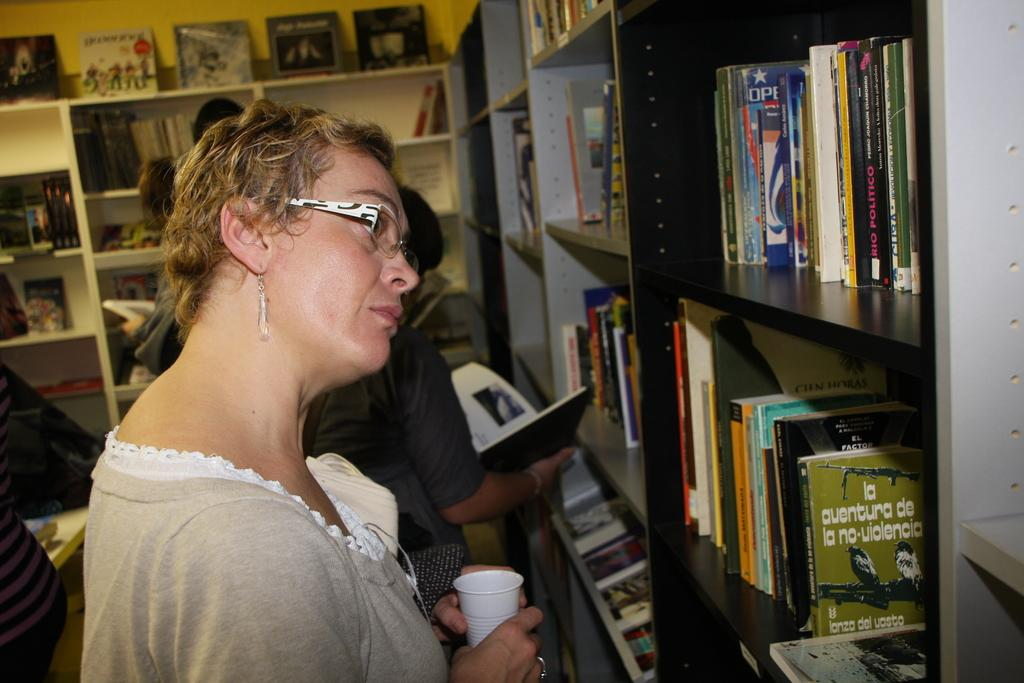Provide a one-sentence caption for the provided image. A woman has her head tilted to read from the bookshelf with many boocks including the green one that starts with "la aventura.". 